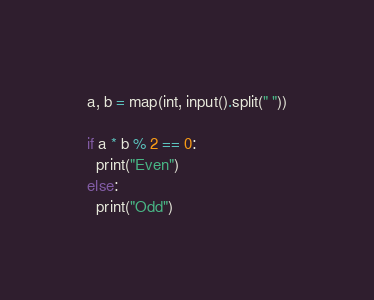<code> <loc_0><loc_0><loc_500><loc_500><_Python_>a, b = map(int, input().split(" "))

if a * b % 2 == 0:
  print("Even")
else:
  print("Odd")</code> 